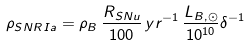<formula> <loc_0><loc_0><loc_500><loc_500>\rho _ { S N R \, I a } = \rho _ { B } \, \frac { R _ { S N u } } { 1 0 0 } \, y r ^ { - 1 } \, \frac { L _ { B , \odot } } { 1 0 ^ { 1 0 } } \delta ^ { - 1 }</formula> 